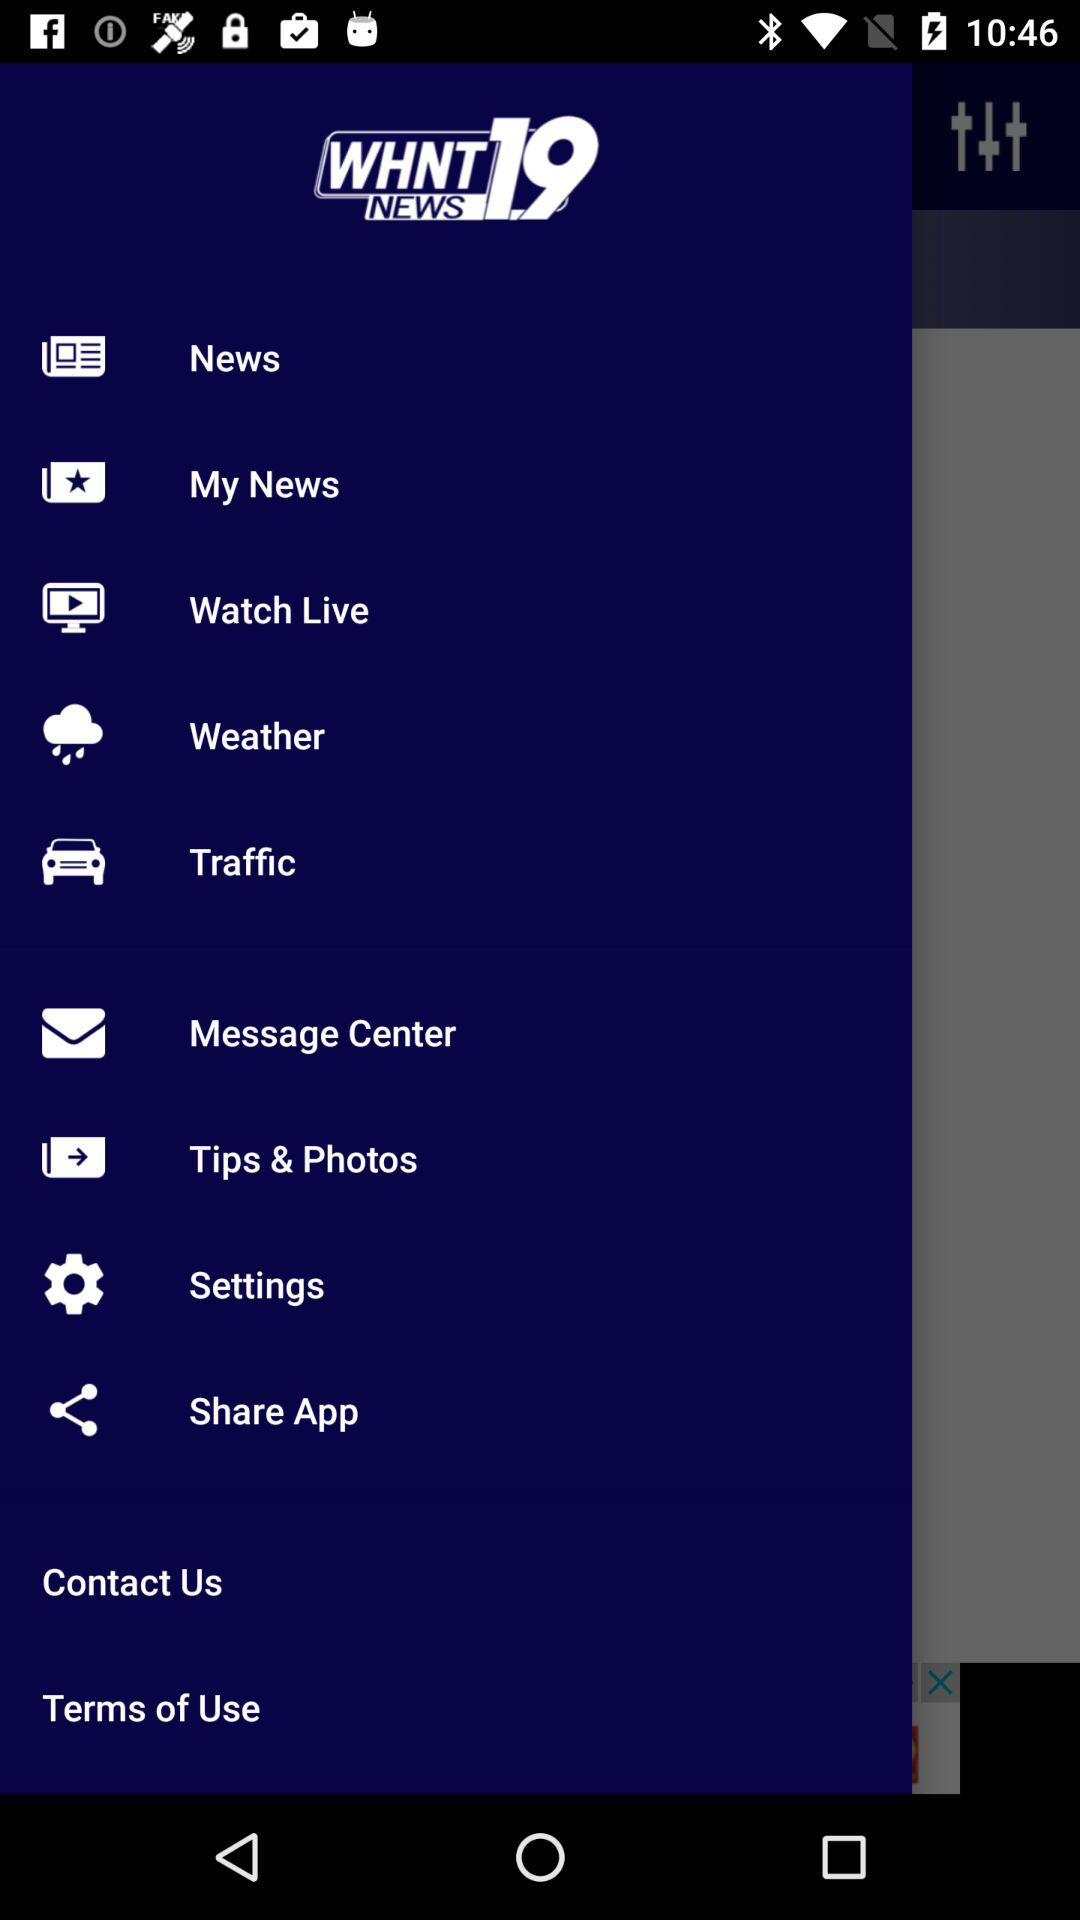What is the news channel name? The news channel name is "WHNT NEWS 19". 